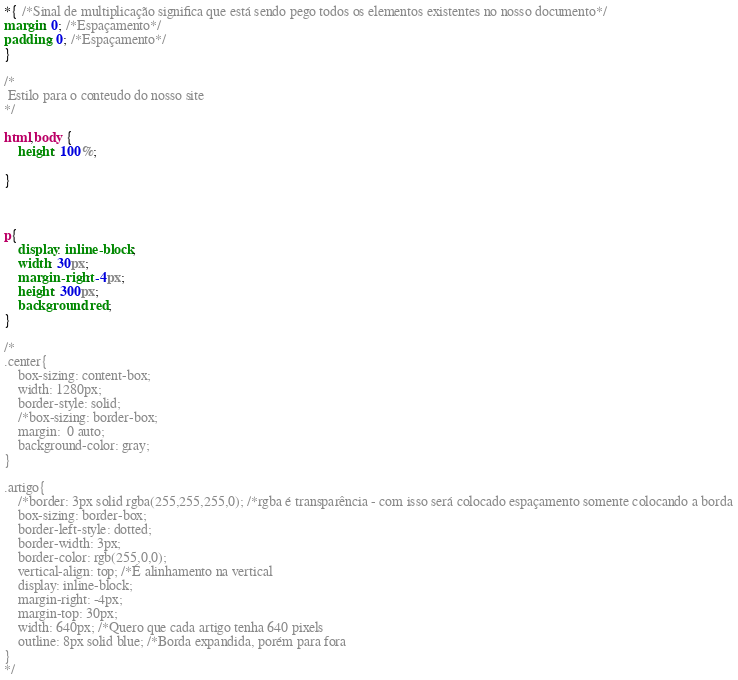<code> <loc_0><loc_0><loc_500><loc_500><_CSS_>*{ /*Sinal de multiplicação significa que está sendo pego todos os elementos existentes no nosso documento*/
margin: 0; /*Espaçamento*/
padding: 0; /*Espaçamento*/
}

/*
 Estilo para o conteudo do nosso site
*/

html,body {
	height: 100%;

}



p{
	display: inline-block;
	width: 30px;
	margin-right: -4px; 
	height: 300px;
	background: red;
}

/*
.center{
	box-sizing: content-box;
	width: 1280px;
	border-style: solid;
	/*box-sizing: border-box;
	margin:  0 auto;
	background-color: gray;
}

.artigo{
	/*border: 3px solid rgba(255,255,255,0); /*rgba é transparência - com isso será colocado espaçamento somente colocando a borda
	box-sizing: border-box;
	border-left-style: dotted;
	border-width: 3px;
	border-color: rgb(255,0,0);
	vertical-align: top; /*É alinhamento na vertical
	display: inline-block;
	margin-right: -4px;
	margin-top: 30px;
	width: 640px; /*Quero que cada artigo tenha 640 pixels
	outline: 8px solid blue; /*Borda expandida, porém para fora
}
*/</code> 